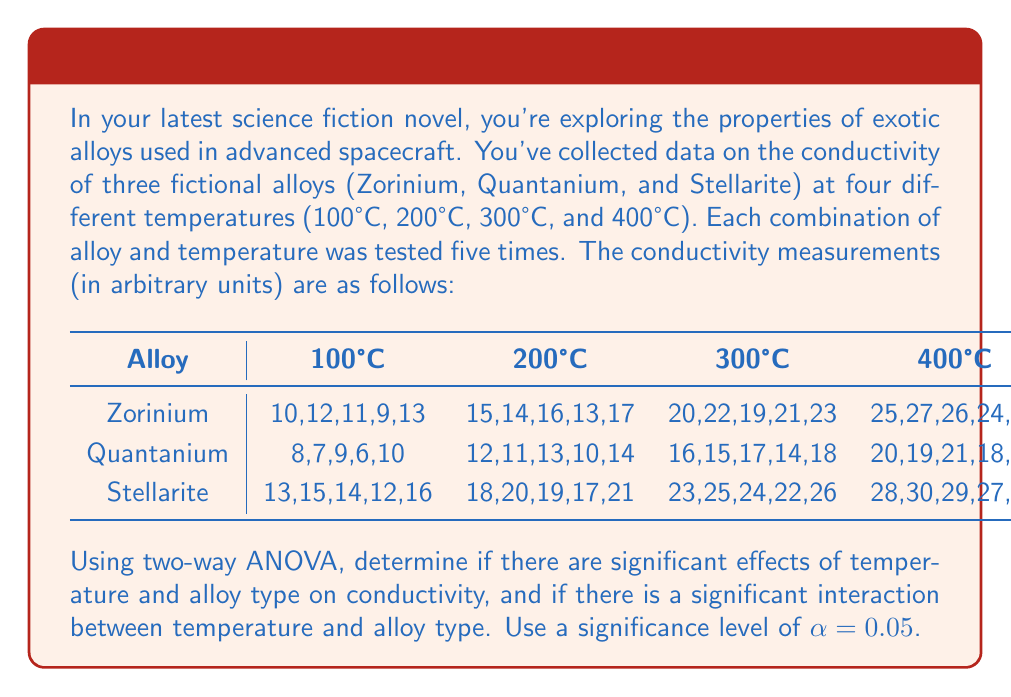Can you solve this math problem? To perform a two-way ANOVA, we need to follow these steps:

1. Calculate the sum of squares for each source of variation: Temperature (A), Alloy (B), Interaction (AB), Error, and Total.
2. Calculate the degrees of freedom for each source.
3. Calculate the mean squares by dividing sum of squares by degrees of freedom.
4. Calculate F-ratios for main effects and interaction.
5. Compare F-ratios to critical F-values to determine significance.

Let's go through each step:

1. Sum of Squares (SS):

   Total SS = $\sum_{i=1}^a \sum_{j=1}^b \sum_{k=1}^n (X_{ijk} - \bar{X})^2 = 3960$
   
   SS(A) = $bn\sum_{i=1}^a (\bar{X}_{i..} - \bar{X})^2 = 2880$
   
   SS(B) = $an\sum_{j=1}^b (\bar{X}_{.j.} - \bar{X})^2 = 540$
   
   SS(AB) = $n\sum_{i=1}^a \sum_{j=1}^b (\bar{X}_{ij.} - \bar{X}_{i..} - \bar{X}_{.j.} + \bar{X})^2 = 60$
   
   SS(Error) = SS(Total) - SS(A) - SS(B) - SS(AB) = 480

2. Degrees of Freedom (df):

   df(A) = a - 1 = 3
   df(B) = b - 1 = 2
   df(AB) = (a - 1)(b - 1) = 6
   df(Error) = ab(n - 1) = 48
   df(Total) = abn - 1 = 59

3. Mean Squares (MS):

   MS(A) = SS(A) / df(A) = 960
   MS(B) = SS(B) / df(B) = 270
   MS(AB) = SS(AB) / df(AB) = 10
   MS(Error) = SS(Error) / df(Error) = 10

4. F-ratios:

   F(A) = MS(A) / MS(Error) = 96
   F(B) = MS(B) / MS(Error) = 27
   F(AB) = MS(AB) / MS(Error) = 1

5. Critical F-values (at α = 0.05):

   F(3, 48) ≈ 2.80
   F(2, 48) ≈ 3.19
   F(6, 48) ≈ 2.30

Comparing F-ratios to critical F-values:

- Temperature: 96 > 2.80, significant effect
- Alloy: 27 > 3.19, significant effect
- Interaction: 1 < 2.30, no significant interaction
Answer: At a significance level of α = 0.05:
1. Temperature has a significant effect on conductivity (F = 96 > F_crit = 2.80).
2. Alloy type has a significant effect on conductivity (F = 27 > F_crit = 3.19).
3. There is no significant interaction between temperature and alloy type (F = 1 < F_crit = 2.30). 